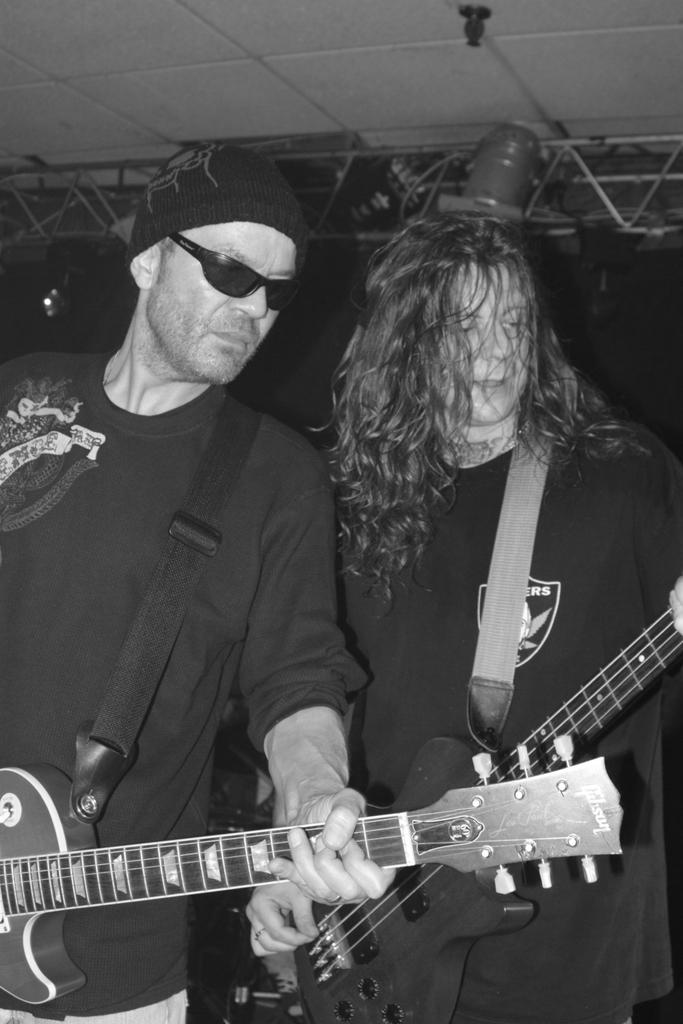How many people are in the foreground of the image? There are two men in the foreground of the image. What are the men doing in the image? The men are standing and holding guitars. What can be seen in the background of the image? There is a ceiling frame visible in the background of the image. What is the purpose of the ceiling frame in the image? The ceiling frame is part of a stage. What type of machine is being used by the men to start their memory in the image? There is no machine or reference to memory in the image; the men are simply standing with guitars. 